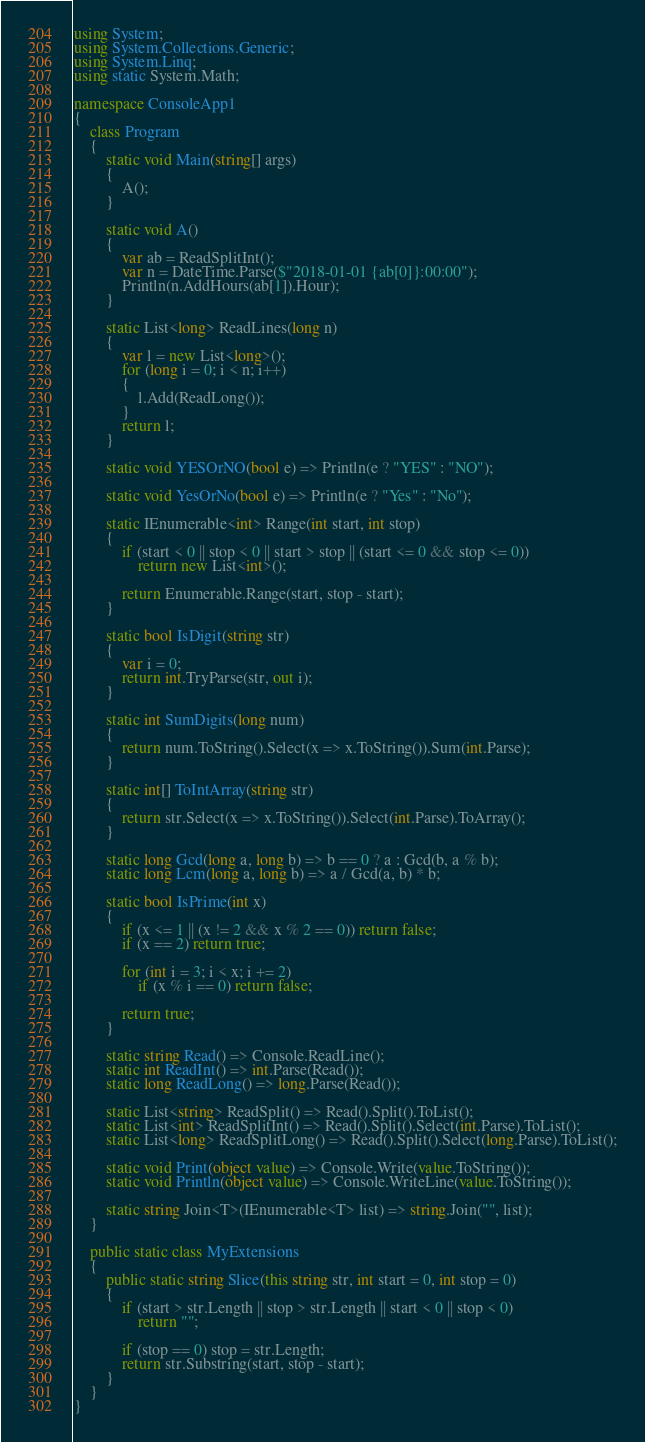<code> <loc_0><loc_0><loc_500><loc_500><_C#_>using System;
using System.Collections.Generic;
using System.Linq;
using static System.Math;

namespace ConsoleApp1
{
    class Program
    {
        static void Main(string[] args)
        {
            A();
        }

        static void A()
        {
            var ab = ReadSplitInt();
            var n = DateTime.Parse($"2018-01-01 {ab[0]}:00:00");
            Println(n.AddHours(ab[1]).Hour);
        }

        static List<long> ReadLines(long n)
        {
            var l = new List<long>();
            for (long i = 0; i < n; i++)
            {
                l.Add(ReadLong());
            }
            return l;
        }

        static void YESOrNO(bool e) => Println(e ? "YES" : "NO");

        static void YesOrNo(bool e) => Println(e ? "Yes" : "No");

        static IEnumerable<int> Range(int start, int stop)
        {
            if (start < 0 || stop < 0 || start > stop || (start <= 0 && stop <= 0))
                return new List<int>();

            return Enumerable.Range(start, stop - start);
        }

        static bool IsDigit(string str)
        {
            var i = 0;
            return int.TryParse(str, out i);
        }

        static int SumDigits(long num)
        {
            return num.ToString().Select(x => x.ToString()).Sum(int.Parse);
        }

        static int[] ToIntArray(string str)
        {
            return str.Select(x => x.ToString()).Select(int.Parse).ToArray();
        }

        static long Gcd(long a, long b) => b == 0 ? a : Gcd(b, a % b);
        static long Lcm(long a, long b) => a / Gcd(a, b) * b;

        static bool IsPrime(int x)
        {
            if (x <= 1 || (x != 2 && x % 2 == 0)) return false;
            if (x == 2) return true;

            for (int i = 3; i < x; i += 2)
                if (x % i == 0) return false;

            return true;
        }

        static string Read() => Console.ReadLine();
        static int ReadInt() => int.Parse(Read());
        static long ReadLong() => long.Parse(Read());

        static List<string> ReadSplit() => Read().Split().ToList();
        static List<int> ReadSplitInt() => Read().Split().Select(int.Parse).ToList();
        static List<long> ReadSplitLong() => Read().Split().Select(long.Parse).ToList();

        static void Print(object value) => Console.Write(value.ToString());
        static void Println(object value) => Console.WriteLine(value.ToString());

        static string Join<T>(IEnumerable<T> list) => string.Join("", list);
    }

    public static class MyExtensions
    {
        public static string Slice(this string str, int start = 0, int stop = 0)
        {
            if (start > str.Length || stop > str.Length || start < 0 || stop < 0)
                return "";

            if (stop == 0) stop = str.Length;
            return str.Substring(start, stop - start);
        }
    }
}
</code> 